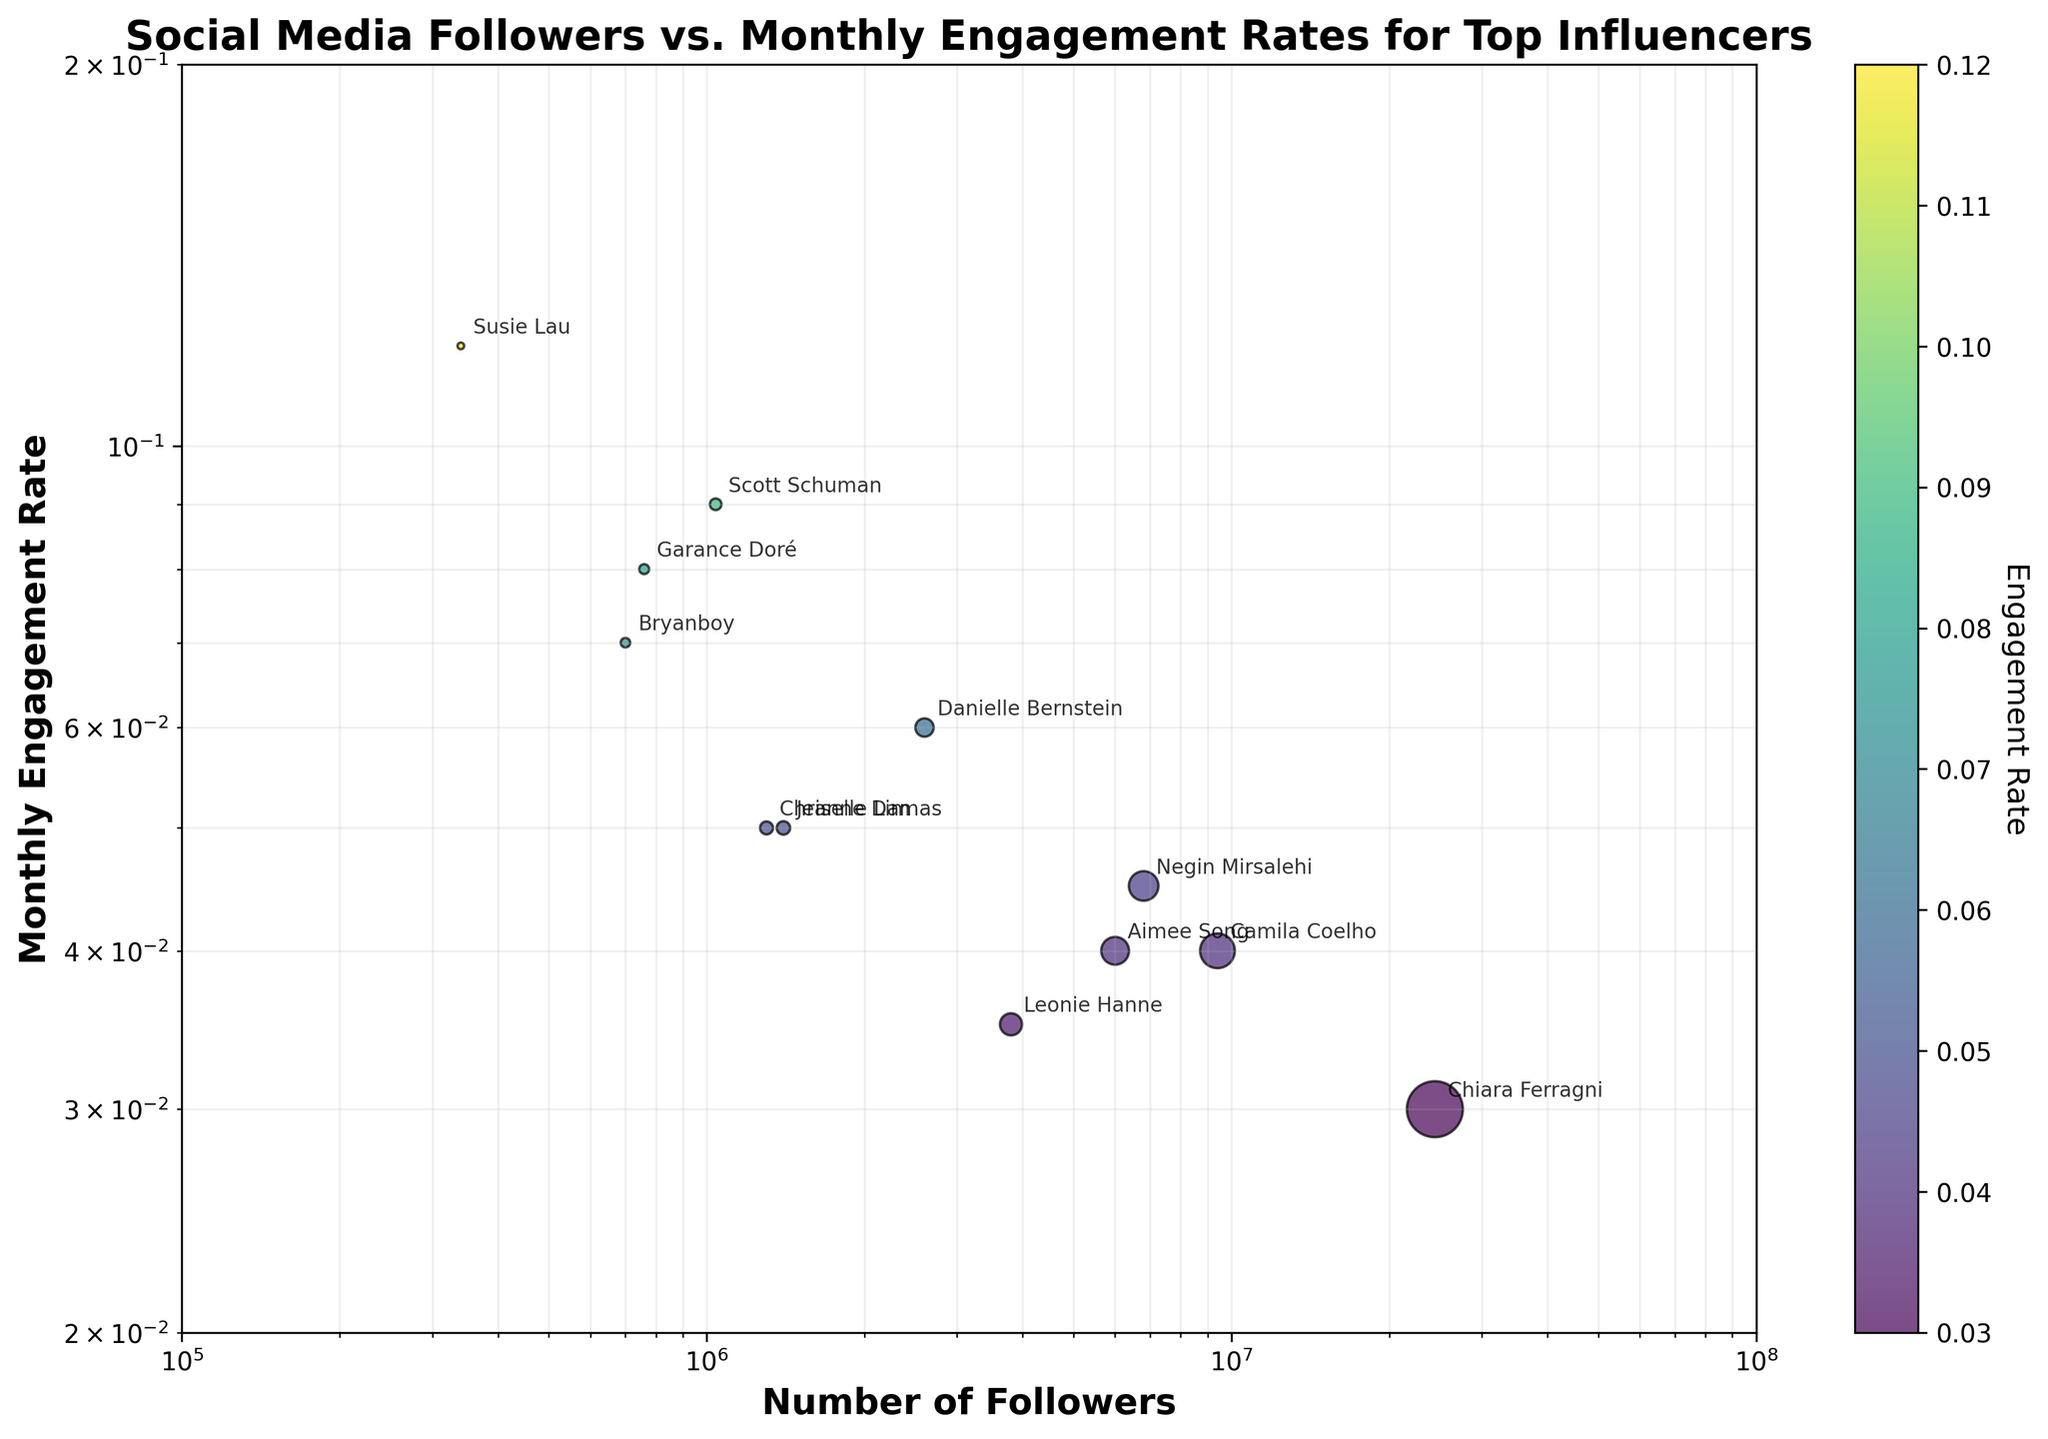What is the title of the figure? The title of the figure is prominently displayed at the top. It provides an overview of what the scatter plot is representing. In this case, it's comparing social media followers and monthly engagement rates for top influencers.
Answer: Social Media Followers vs. Monthly Engagement Rates for Top Influencers Which influencer has the highest monthly engagement rate? Locate the highest point on the y-axis representing the monthly engagement rate, then read the label associated with that point.
Answer: Susie Lau Which influencer has the most followers? Locate the point furthest to the right on the x-axis representing the number of followers, then read the label associated with that point.
Answer: Chiara Ferragni What is the range of followers displayed on the x-axis? The x-axis has a logarithmic scale and shows the range from the smallest to the largest value in followers. Read the scale to determine these values.
Answer: 100,000 to 100,000,000 Between Danielle Bernstein and Camila Coelho, who has a higher monthly engagement rate? Find the points associated with Danielle Bernstein and Camila Coelho on the scatter plot. Compare their positions on the y-axis.
Answer: Danielle Bernstein Which influencer falls closest to the middle of the plot both horizontally and vertically? Visually identify the point that sits roughly in the center of the scatter plot, considering both the x and y axes.
Answer: Leonie Hanne What is the approximate engagement rate of influencers with around 1 million followers? Identify the data points around the 1 million followers mark on the x-axis and observe their corresponding y-axis values. Average these values.
Answer: Approximately 0.05 How does the dot size relate to the number of followers? The size of the dots represents the number of followers. The legend or the scaling in the plot description indicates that dots are sized proportionally to the number of followers.
Answer: Larger dots mean more followers Which influencers appear to have a high engagement rate despite having fewer followers? Identify the points located towards the left side of the plot on the x-axis but higher up on the y-axis, indicating fewer followers but higher engagement rates.
Answer: Susie Lau, Bryanboy, Scott Schuman, and Garance Doré Do most influencers have an engagement rate above or below 0.05? Look at the y-axis and count the number of points above and below the 0.05 mark to find where the majority lie.
Answer: Below 0.05 